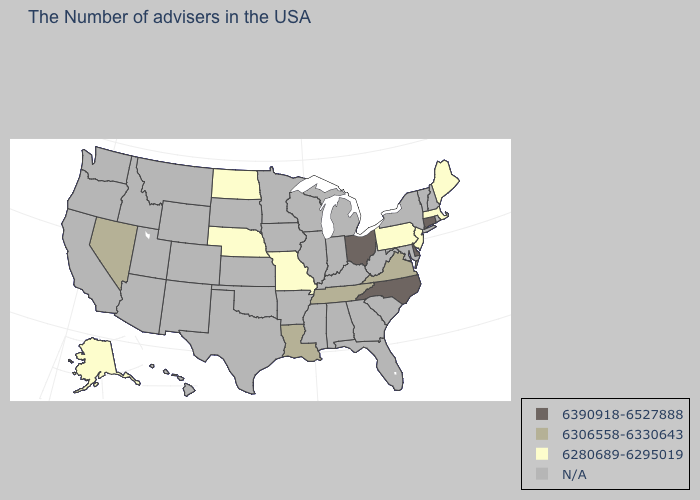Name the states that have a value in the range N/A?
Concise answer only. Rhode Island, New Hampshire, Vermont, New York, Maryland, South Carolina, West Virginia, Florida, Georgia, Michigan, Kentucky, Indiana, Alabama, Wisconsin, Illinois, Mississippi, Arkansas, Minnesota, Iowa, Kansas, Oklahoma, Texas, South Dakota, Wyoming, Colorado, New Mexico, Utah, Montana, Arizona, Idaho, California, Washington, Oregon, Hawaii. Does the map have missing data?
Concise answer only. Yes. Is the legend a continuous bar?
Write a very short answer. No. What is the value of Mississippi?
Keep it brief. N/A. Name the states that have a value in the range N/A?
Keep it brief. Rhode Island, New Hampshire, Vermont, New York, Maryland, South Carolina, West Virginia, Florida, Georgia, Michigan, Kentucky, Indiana, Alabama, Wisconsin, Illinois, Mississippi, Arkansas, Minnesota, Iowa, Kansas, Oklahoma, Texas, South Dakota, Wyoming, Colorado, New Mexico, Utah, Montana, Arizona, Idaho, California, Washington, Oregon, Hawaii. What is the value of Maine?
Short answer required. 6280689-6295019. What is the value of Oregon?
Keep it brief. N/A. What is the value of Iowa?
Be succinct. N/A. Does Ohio have the highest value in the MidWest?
Short answer required. Yes. Among the states that border California , which have the lowest value?
Give a very brief answer. Nevada. Name the states that have a value in the range 6390918-6527888?
Be succinct. Connecticut, Delaware, North Carolina, Ohio. Which states have the highest value in the USA?
Concise answer only. Connecticut, Delaware, North Carolina, Ohio. Does the map have missing data?
Quick response, please. Yes. What is the value of Texas?
Quick response, please. N/A. 